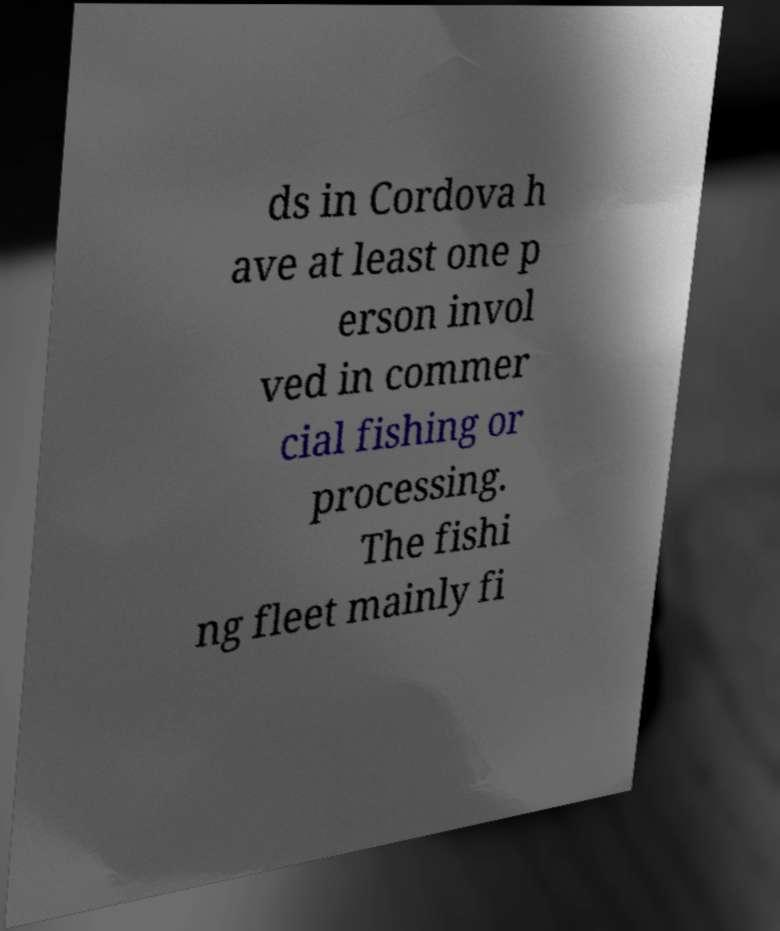Please identify and transcribe the text found in this image. ds in Cordova h ave at least one p erson invol ved in commer cial fishing or processing. The fishi ng fleet mainly fi 